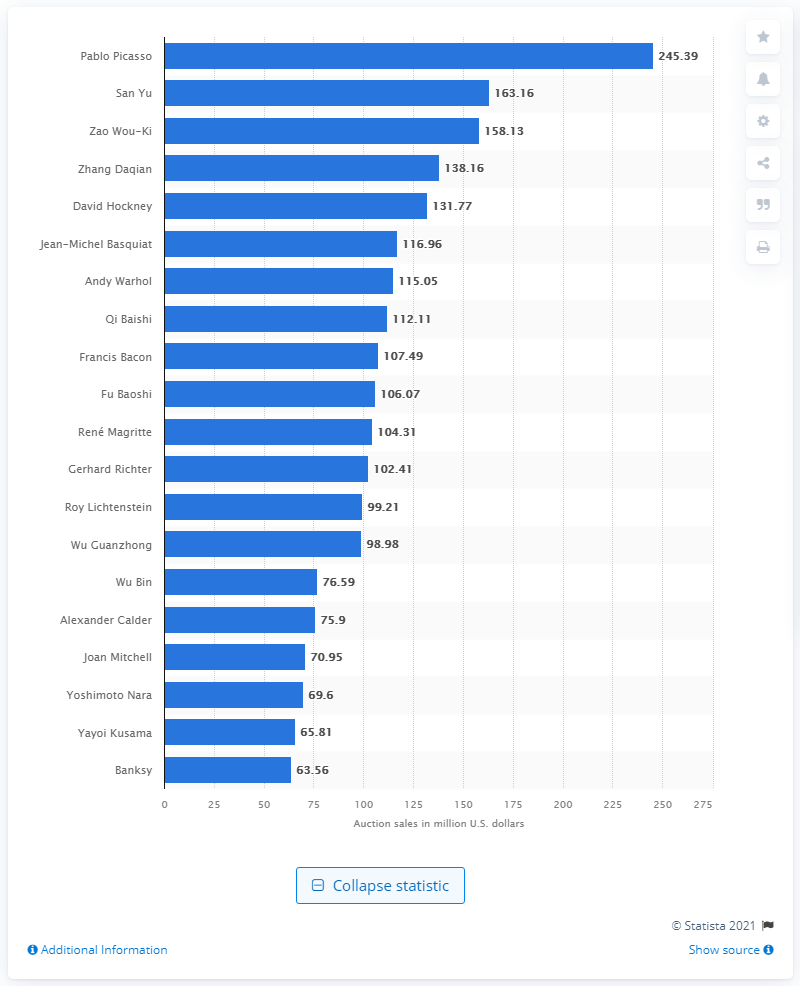Highlight a few significant elements in this photo. In 2020, the total revenue generated from Pablo Picasso auctions was 245.39 million dollars. The revenues of fine art auctions dedicated to Pablo Picasso were 245.39 million dollars. 